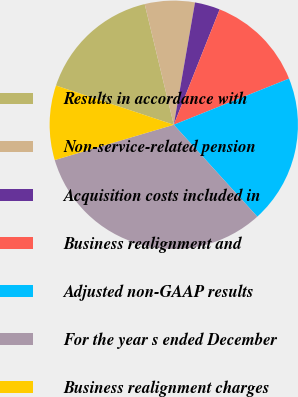Convert chart to OTSL. <chart><loc_0><loc_0><loc_500><loc_500><pie_chart><fcel>Results in accordance with<fcel>Non-service-related pension<fcel>Acquisition costs included in<fcel>Business realignment and<fcel>Adjusted non-GAAP results<fcel>For the year s ended December<fcel>Business realignment charges<nl><fcel>16.12%<fcel>6.5%<fcel>3.29%<fcel>12.91%<fcel>19.32%<fcel>32.15%<fcel>9.7%<nl></chart> 